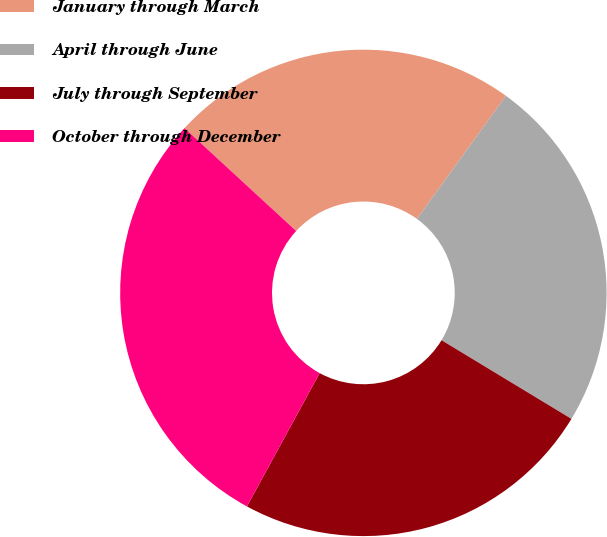<chart> <loc_0><loc_0><loc_500><loc_500><pie_chart><fcel>January through March<fcel>April through June<fcel>July through September<fcel>October through December<nl><fcel>23.12%<fcel>23.7%<fcel>24.28%<fcel>28.9%<nl></chart> 